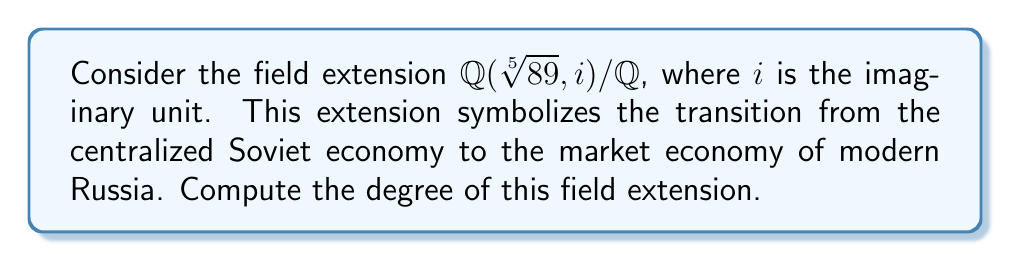Show me your answer to this math problem. Let's approach this step-by-step:

1) First, we need to consider the tower of extensions:
   $\mathbb{Q} \subset \mathbb{Q}(\sqrt[5]{89}) \subset \mathbb{Q}(\sqrt[5]{89}, i)$

2) For the first extension $\mathbb{Q}(\sqrt[5]{89}) / \mathbb{Q}$:
   - The polynomial $x^5 - 89$ is irreducible over $\mathbb{Q}$ by Eisenstein's criterion (with prime $p = 89$).
   - Therefore, $[\mathbb{Q}(\sqrt[5]{89}) : \mathbb{Q}] = 5$

3) For the second extension $\mathbb{Q}(\sqrt[5]{89}, i) / \mathbb{Q}(\sqrt[5]{89})$:
   - We're adding $i$, which satisfies $x^2 + 1 = 0$.
   - This polynomial is irreducible over $\mathbb{Q}(\sqrt[5]{89})$ as it's irreducible over $\mathbb{R}$.
   - Therefore, $[\mathbb{Q}(\sqrt[5]{89}, i) : \mathbb{Q}(\sqrt[5]{89})] = 2$

4) By the multiplicativity of degrees in tower extensions:
   $[\mathbb{Q}(\sqrt[5]{89}, i) : \mathbb{Q}] = [\mathbb{Q}(\sqrt[5]{89}, i) : \mathbb{Q}(\sqrt[5]{89})] \cdot [\mathbb{Q}(\sqrt[5]{89}) : \mathbb{Q}]$

5) Substituting the values:
   $[\mathbb{Q}(\sqrt[5]{89}, i) : \mathbb{Q}] = 2 \cdot 5 = 10$

This degree of 10 symbolizes the complex and multifaceted nature of the economic transition, reflecting both the five-year plans of the Soviet era (represented by the fifth root) and the duality of the old and new systems (represented by the imaginary unit).
Answer: 10 